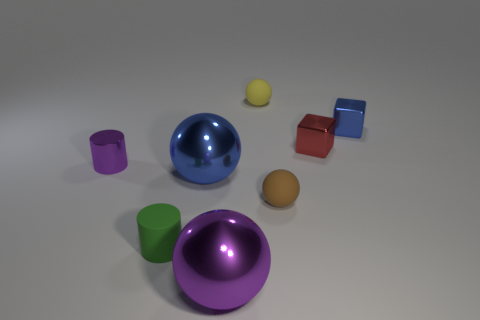Could you describe the positioning of the objects? Certainly! The objects are scattered around the central part of the image with no apparent pattern, as if they've been placed without specific order or arrangement on a flat surface. Is there any object that stands out in particular? Indeed, the large, blue, glossy sphere commands attention due to its size and reflective surface which contrasts with the matte textures of some other objects. 